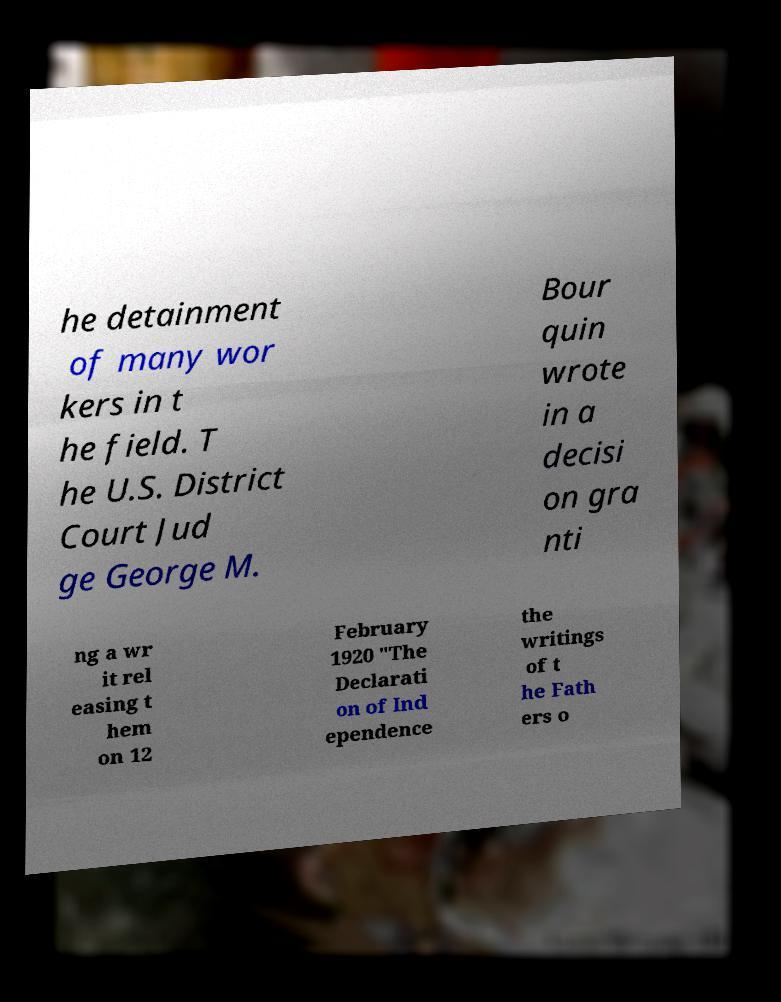Could you extract and type out the text from this image? he detainment of many wor kers in t he field. T he U.S. District Court Jud ge George M. Bour quin wrote in a decisi on gra nti ng a wr it rel easing t hem on 12 February 1920 "The Declarati on of Ind ependence the writings of t he Fath ers o 